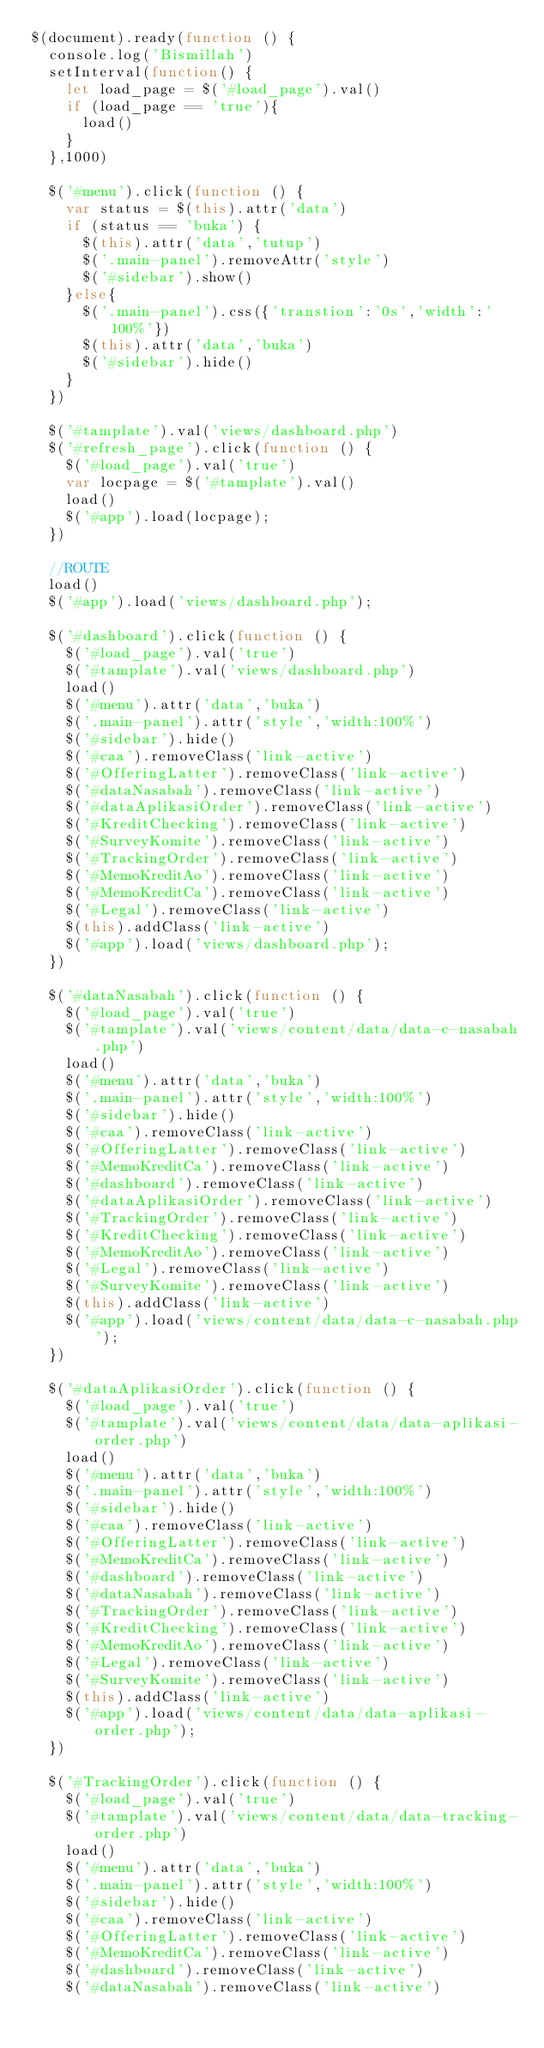<code> <loc_0><loc_0><loc_500><loc_500><_JavaScript_>$(document).ready(function () {
	console.log('Bismillah')
	setInterval(function() {
		let load_page = $('#load_page').val()
		if (load_page == 'true'){
			load()
		}
	},1000)

	$('#menu').click(function () {
		var status = $(this).attr('data')
		if (status == 'buka') {
			$(this).attr('data','tutup')
			$('.main-panel').removeAttr('style')
			$('#sidebar').show()
		}else{
			$('.main-panel').css({'transtion':'0s','width':'100%'})
			$(this).attr('data','buka')
			$('#sidebar').hide()
		}
	})

	$('#tamplate').val('views/dashboard.php')
	$('#refresh_page').click(function () {
		$('#load_page').val('true')
		var locpage = $('#tamplate').val()
		load()
		$('#app').load(locpage);
	})

	//ROUTE
	load()
	$('#app').load('views/dashboard.php');

	$('#dashboard').click(function () {
		$('#load_page').val('true')
		$('#tamplate').val('views/dashboard.php')
		load()
		$('#menu').attr('data','buka')
		$('.main-panel').attr('style','width:100%')
		$('#sidebar').hide()
		$('#caa').removeClass('link-active')
		$('#OfferingLatter').removeClass('link-active')
		$('#dataNasabah').removeClass('link-active')
		$('#dataAplikasiOrder').removeClass('link-active')
		$('#KreditChecking').removeClass('link-active')
		$('#SurveyKomite').removeClass('link-active')
		$('#TrackingOrder').removeClass('link-active')
		$('#MemoKreditAo').removeClass('link-active')
		$('#MemoKreditCa').removeClass('link-active')
		$('#Legal').removeClass('link-active')
		$(this).addClass('link-active')
		$('#app').load('views/dashboard.php');
	})

	$('#dataNasabah').click(function () {
		$('#load_page').val('true')
		$('#tamplate').val('views/content/data/data-c-nasabah.php')
		load()
		$('#menu').attr('data','buka')
		$('.main-panel').attr('style','width:100%')
		$('#sidebar').hide()
		$('#caa').removeClass('link-active')
		$('#OfferingLatter').removeClass('link-active')
		$('#MemoKreditCa').removeClass('link-active')
		$('#dashboard').removeClass('link-active')
		$('#dataAplikasiOrder').removeClass('link-active')
		$('#TrackingOrder').removeClass('link-active')
		$('#KreditChecking').removeClass('link-active')
		$('#MemoKreditAo').removeClass('link-active')
		$('#Legal').removeClass('link-active')
		$('#SurveyKomite').removeClass('link-active')
		$(this).addClass('link-active')
		$('#app').load('views/content/data/data-c-nasabah.php');
	})

	$('#dataAplikasiOrder').click(function () {
		$('#load_page').val('true')
		$('#tamplate').val('views/content/data/data-aplikasi-order.php')
		load()
		$('#menu').attr('data','buka')
		$('.main-panel').attr('style','width:100%')
		$('#sidebar').hide()
		$('#caa').removeClass('link-active')
		$('#OfferingLatter').removeClass('link-active')
		$('#MemoKreditCa').removeClass('link-active')
		$('#dashboard').removeClass('link-active')
		$('#dataNasabah').removeClass('link-active')
		$('#TrackingOrder').removeClass('link-active')
		$('#KreditChecking').removeClass('link-active')
		$('#MemoKreditAo').removeClass('link-active')
		$('#Legal').removeClass('link-active')
		$('#SurveyKomite').removeClass('link-active')
		$(this).addClass('link-active')
		$('#app').load('views/content/data/data-aplikasi-order.php');
	})

	$('#TrackingOrder').click(function () {
		$('#load_page').val('true')
		$('#tamplate').val('views/content/data/data-tracking-order.php')
		load()
		$('#menu').attr('data','buka')
		$('.main-panel').attr('style','width:100%')
		$('#sidebar').hide()
		$('#caa').removeClass('link-active')
		$('#OfferingLatter').removeClass('link-active')
		$('#MemoKreditCa').removeClass('link-active')
		$('#dashboard').removeClass('link-active')
		$('#dataNasabah').removeClass('link-active')</code> 